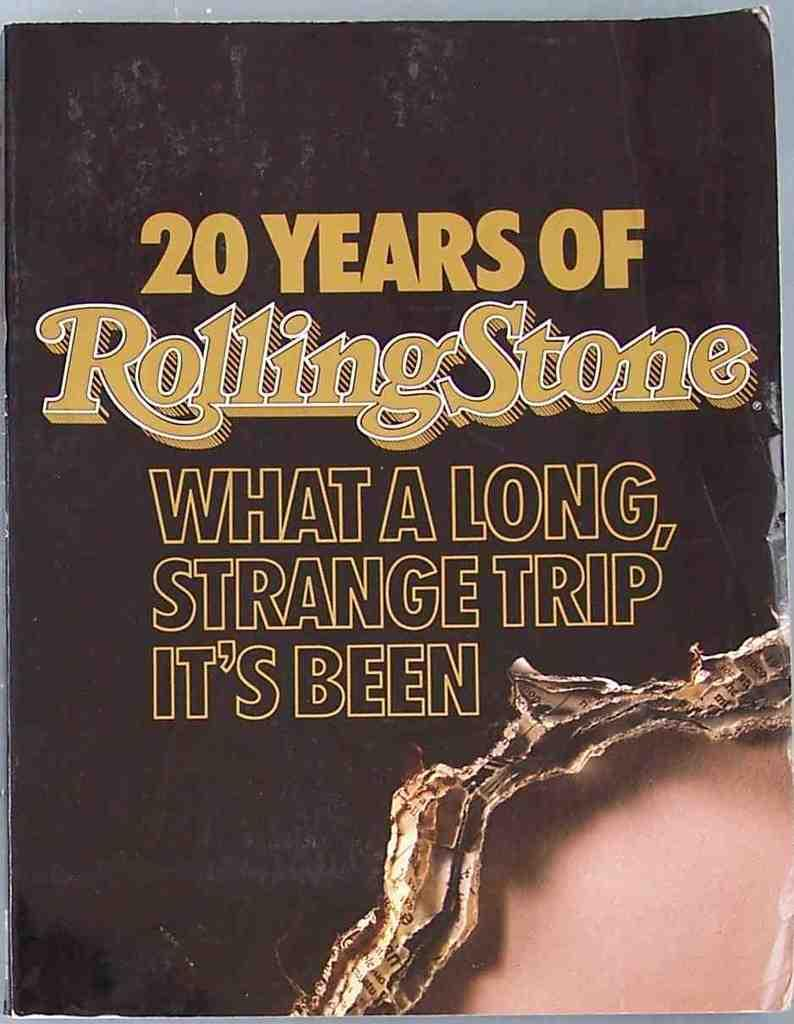<image>
Present a compact description of the photo's key features. A magazine cover titled "20 Year of Rolling Stone" 